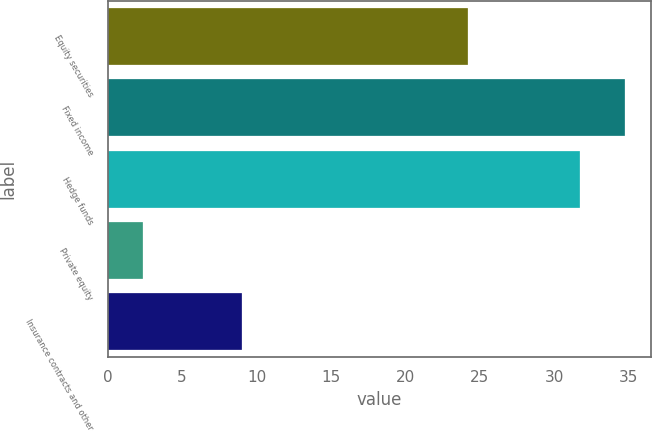Convert chart to OTSL. <chart><loc_0><loc_0><loc_500><loc_500><bar_chart><fcel>Equity securities<fcel>Fixed income<fcel>Hedge funds<fcel>Private equity<fcel>Insurance contracts and other<nl><fcel>24.2<fcel>34.73<fcel>31.7<fcel>2.4<fcel>9<nl></chart> 